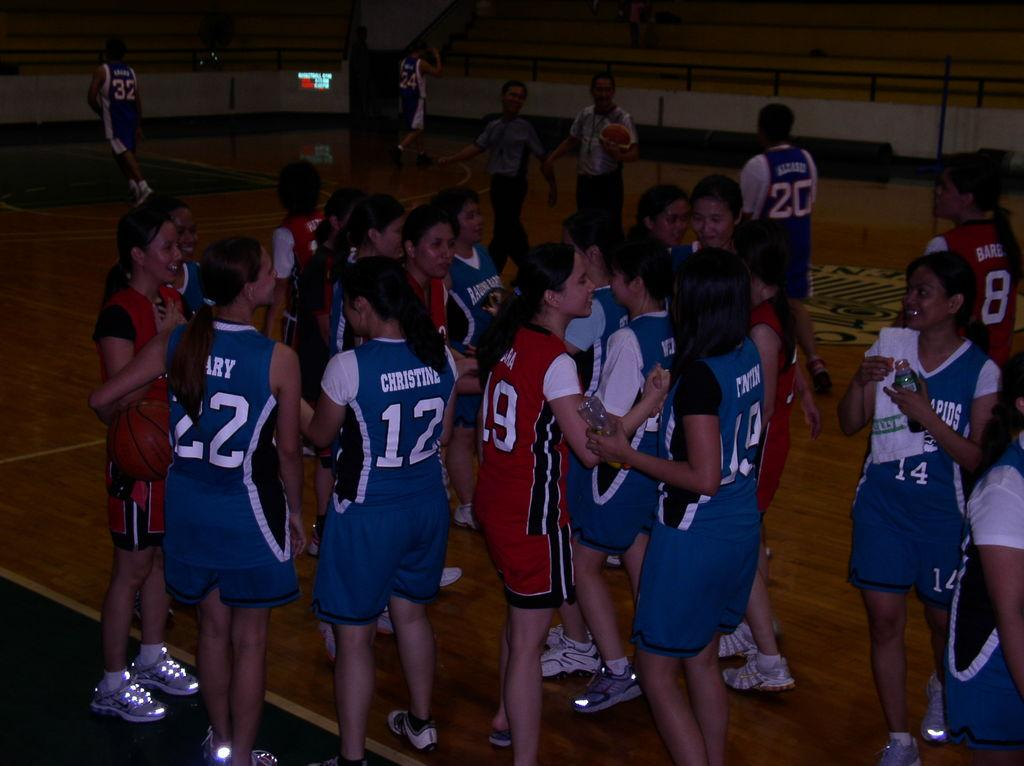<image>
Write a terse but informative summary of the picture. a few players with one girl wearing number 12 